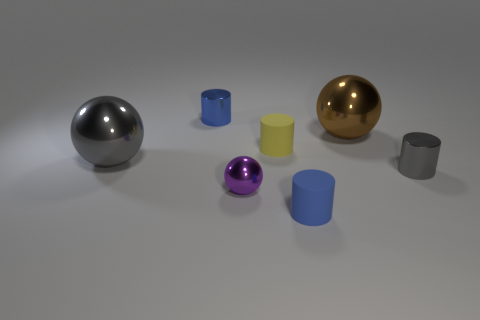Which object stands out the most and why? The gold sphere stands out the most because of its reflective surface and vibrant color that catches the eye amidst the more subdued hues of the other objects. 